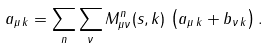<formula> <loc_0><loc_0><loc_500><loc_500>a _ { \mu \, { k } } = \sum _ { n } \sum _ { \nu } M ^ { n } _ { \mu \nu } ( s , { k } ) \, \left ( a _ { \mu \, { k } } + b _ { \nu \, { k } } \right ) .</formula> 